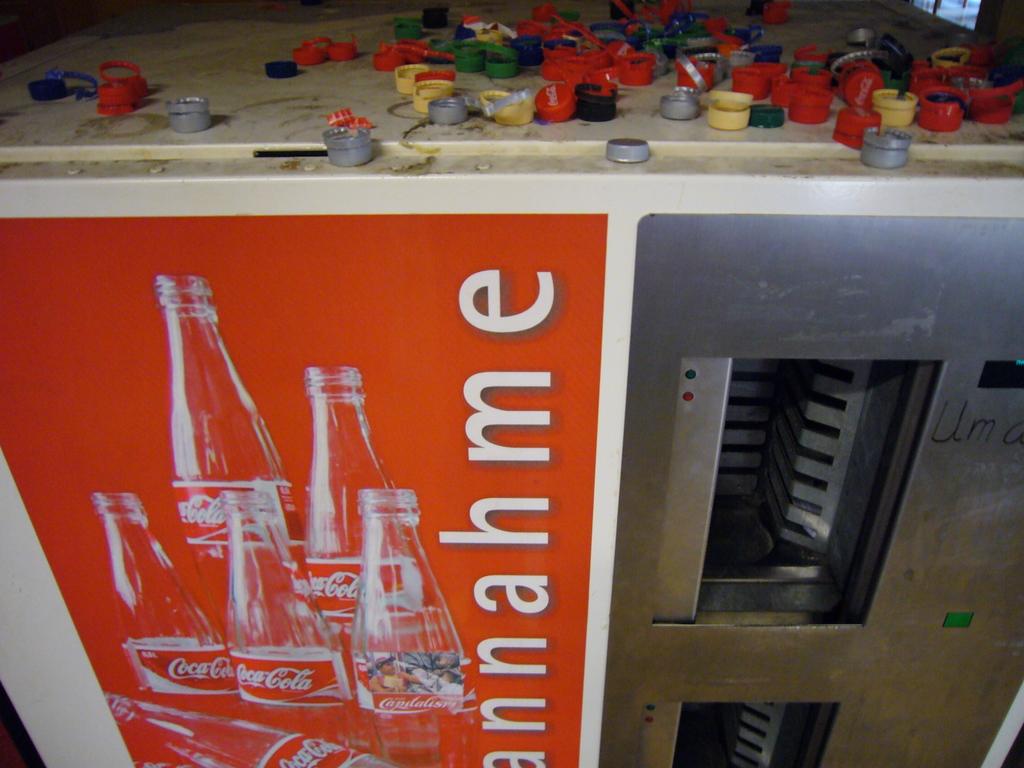What brand of soda is shown in the poster?
Offer a terse response. Coca cola. Is this an old vending machine?
Ensure brevity in your answer.  Unanswerable. 